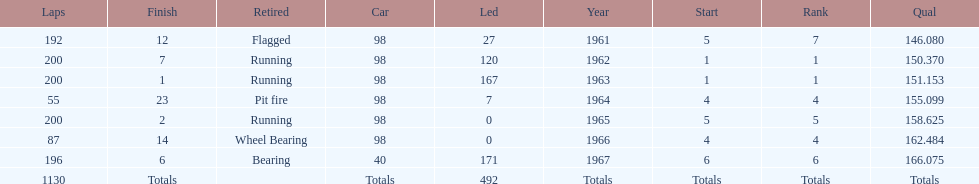What was his best finish before his first win? 7. 